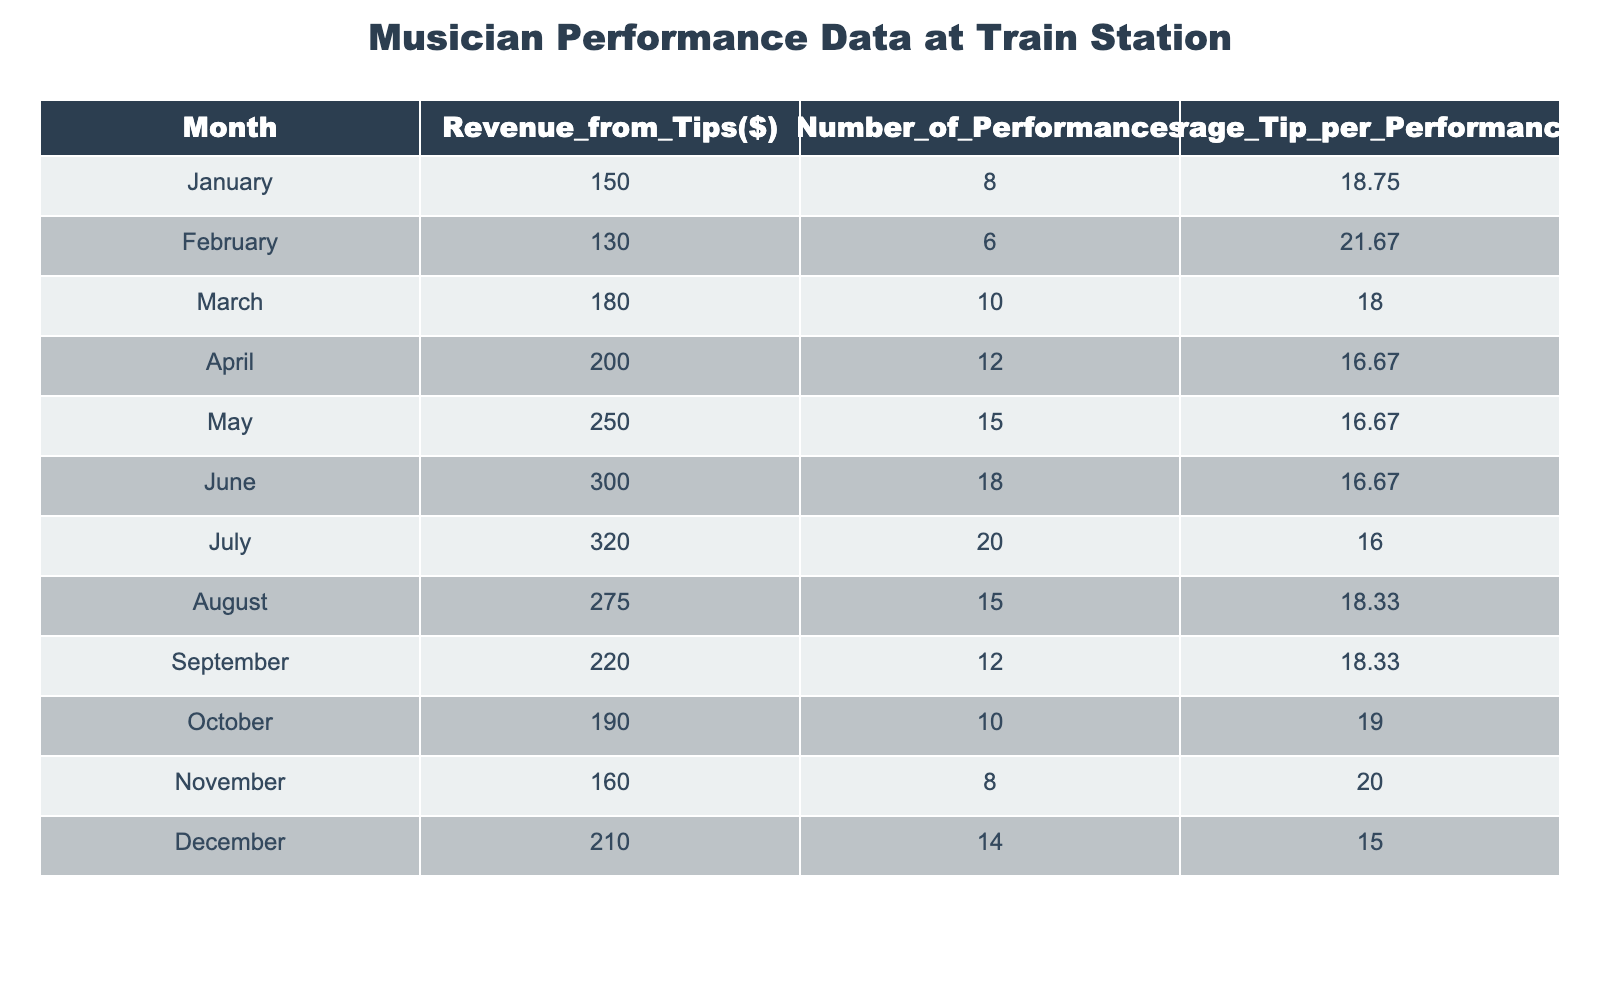What was the highest revenue generated from tips in a single month? The table shows the revenue generated from tips for each month. Looking through the "Revenue_from_Tips($)" column, May has the highest value at 250 dollars.
Answer: 250 Which month had the least number of performances? By examining the "Number_of_Performances" column, February shows the least number of performances with a total of 6.
Answer: 6 What is the average tip per performance in August? The "Average_Tip_per_Performance($)" column indicates that in August, the average tip per performance is 18.33 dollars.
Answer: 18.33 Over the year, what was the total revenue from tips? To find the total revenue, we need to sum the values in the "Revenue_from_Tips($)" column: 150 + 130 + 180 + 200 + 250 + 300 + 320 + 275 + 220 + 190 + 160 + 210 = 2,300 dollars.
Answer: 2300 Was there an increase in the number of performances from January to April? The number of performances for January is 8 and for April is 12. Since 12 is greater than 8, there was indeed an increase.
Answer: Yes What was the average number of performances across all months? We can calculate this by summing the number of performances (8 + 6 + 10 + 12 + 15 + 18 + 20 + 15 + 12 + 10 + 8 + 14 =  0) and then dividing by 12 (the number of months). The total is  0 and so the average is calculated as 0 / 12 = 14. The average number of performances is therefore 14.
Answer: 14 Did the average tip per performance increase from March to July? In March, the average tip per performance is 18.00, while in July it is 16.00. Since 16.00 is less than 18.00, there was no increase.
Answer: No How does the total revenue generated in the second half of the year compare to the first half? Total revenue for the first half (January to June) is 150 + 130 + 180 + 200 + 250 + 300 = 1210 dollars. For the second half (July to December) the total is 320 + 275 + 220 + 190 + 160 + 210 = 1475 dollars. The second half (1475) is greater than the first half (1210), indicating more revenue overall in the second half of the year.
Answer: Second half is greater What was the month with the highest average tip per performance? By looking at the "Average_Tip_per_Performance($)" column, February has the highest average tip at 21.67 dollars.
Answer: 21.67 